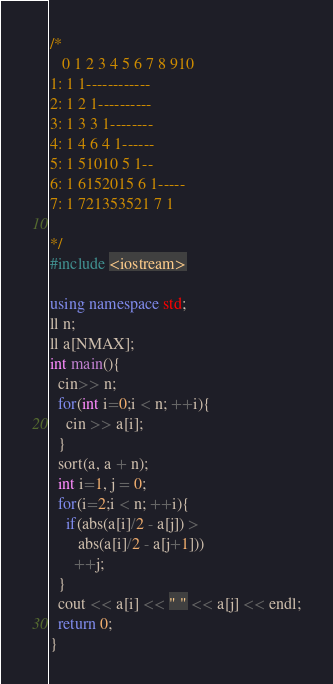Convert code to text. <code><loc_0><loc_0><loc_500><loc_500><_C++_>/*
   0 1 2 3 4 5 6 7 8 910
1: 1 1------------
2: 1 2 1----------
3: 1 3 3 1--------
4: 1 4 6 4 1------
5: 1 51010 5 1--
6: 1 6152015 6 1-----
7: 1 721353521 7 1

*/
#include <iostream>

using namespace std;
ll n;
ll a[NMAX];
int main(){
  cin>> n;
  for(int i=0;i < n; ++i){
    cin >> a[i];
  }
  sort(a, a + n);
  int i=1, j = 0;
  for(i=2;i < n; ++i){
    if(abs(a[i]/2 - a[j]) > 
       abs(a[i]/2 - a[j+1]))
      ++j;
  }
  cout << a[i] << " " << a[j] << endl;
  return 0;
}</code> 